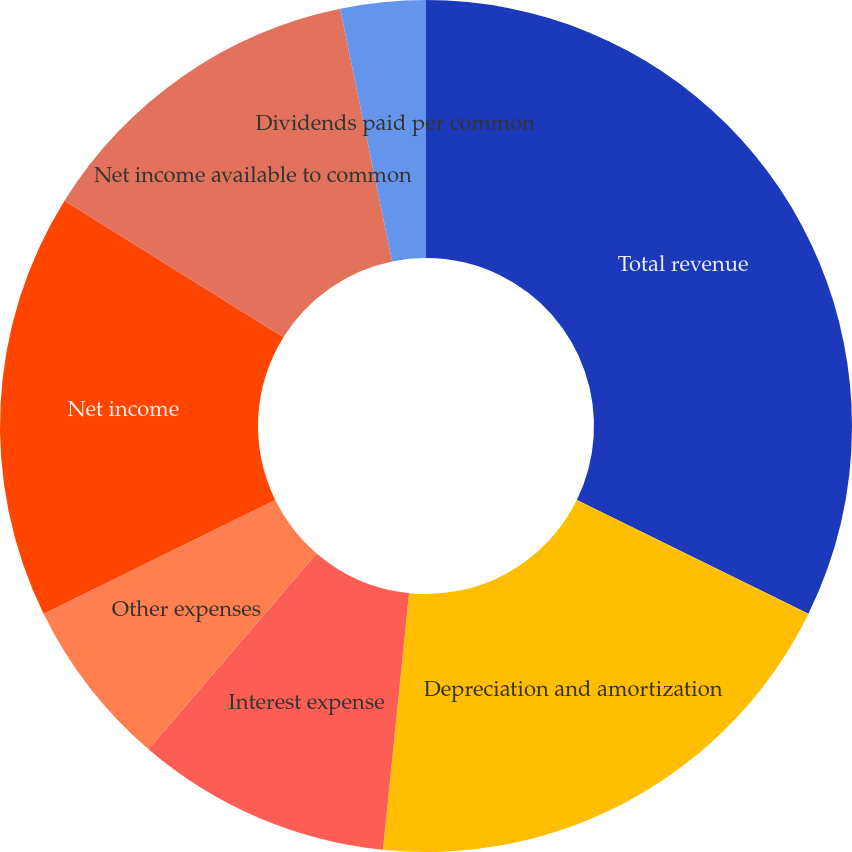Convert chart to OTSL. <chart><loc_0><loc_0><loc_500><loc_500><pie_chart><fcel>Total revenue<fcel>Depreciation and amortization<fcel>Interest expense<fcel>Other expenses<fcel>Net income<fcel>Net income available to common<fcel>Basic and diluted<fcel>Dividends paid per common<nl><fcel>32.26%<fcel>19.35%<fcel>9.68%<fcel>6.45%<fcel>16.13%<fcel>12.9%<fcel>0.0%<fcel>3.23%<nl></chart> 